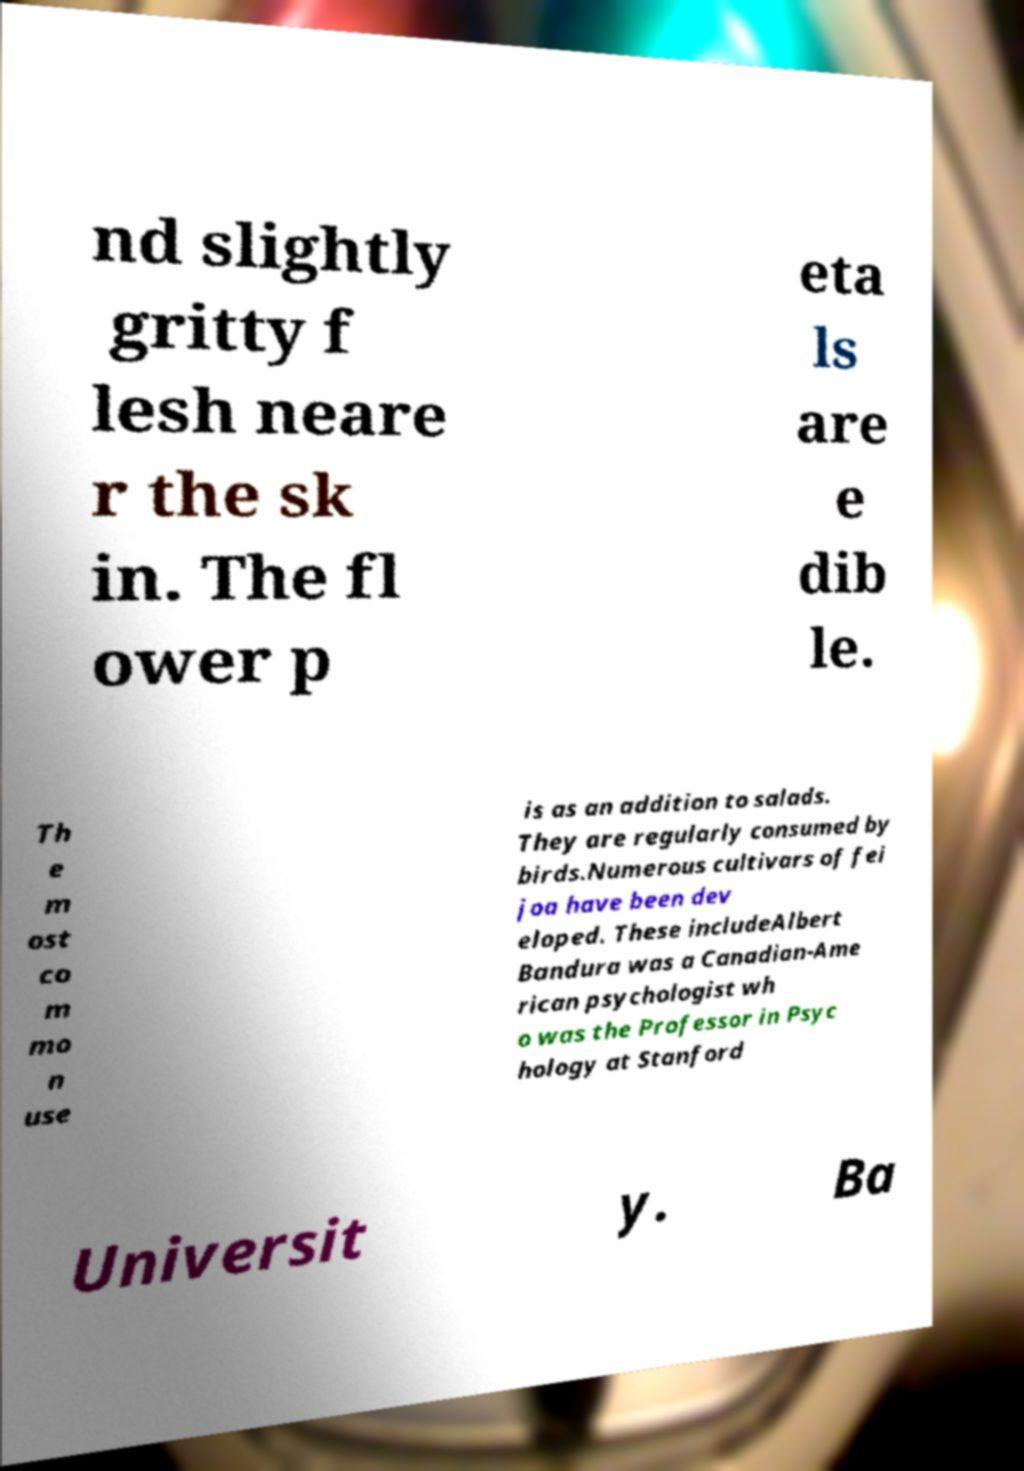Could you extract and type out the text from this image? nd slightly gritty f lesh neare r the sk in. The fl ower p eta ls are e dib le. Th e m ost co m mo n use is as an addition to salads. They are regularly consumed by birds.Numerous cultivars of fei joa have been dev eloped. These includeAlbert Bandura was a Canadian-Ame rican psychologist wh o was the Professor in Psyc hology at Stanford Universit y. Ba 